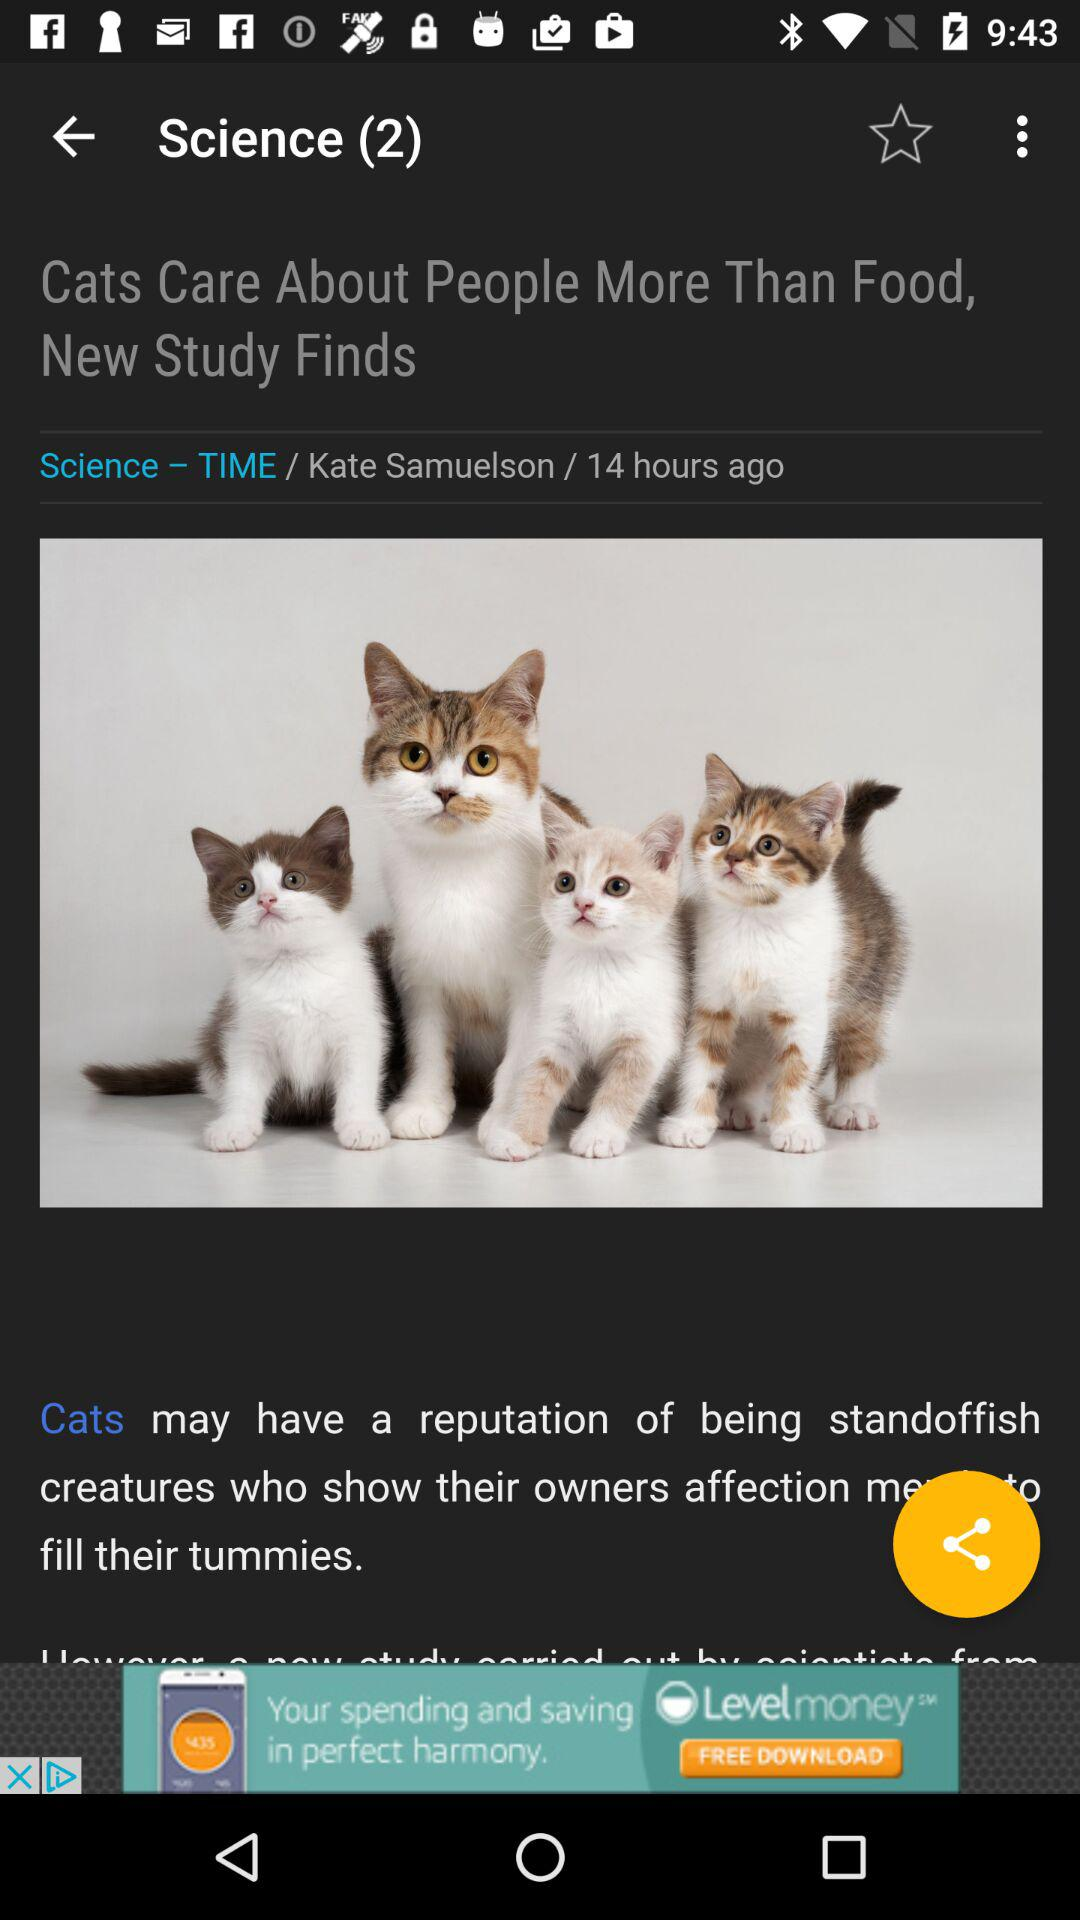What kind of cat is in the picture?
When the provided information is insufficient, respond with <no answer>. <no answer> 